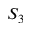<formula> <loc_0><loc_0><loc_500><loc_500>S _ { 3 }</formula> 